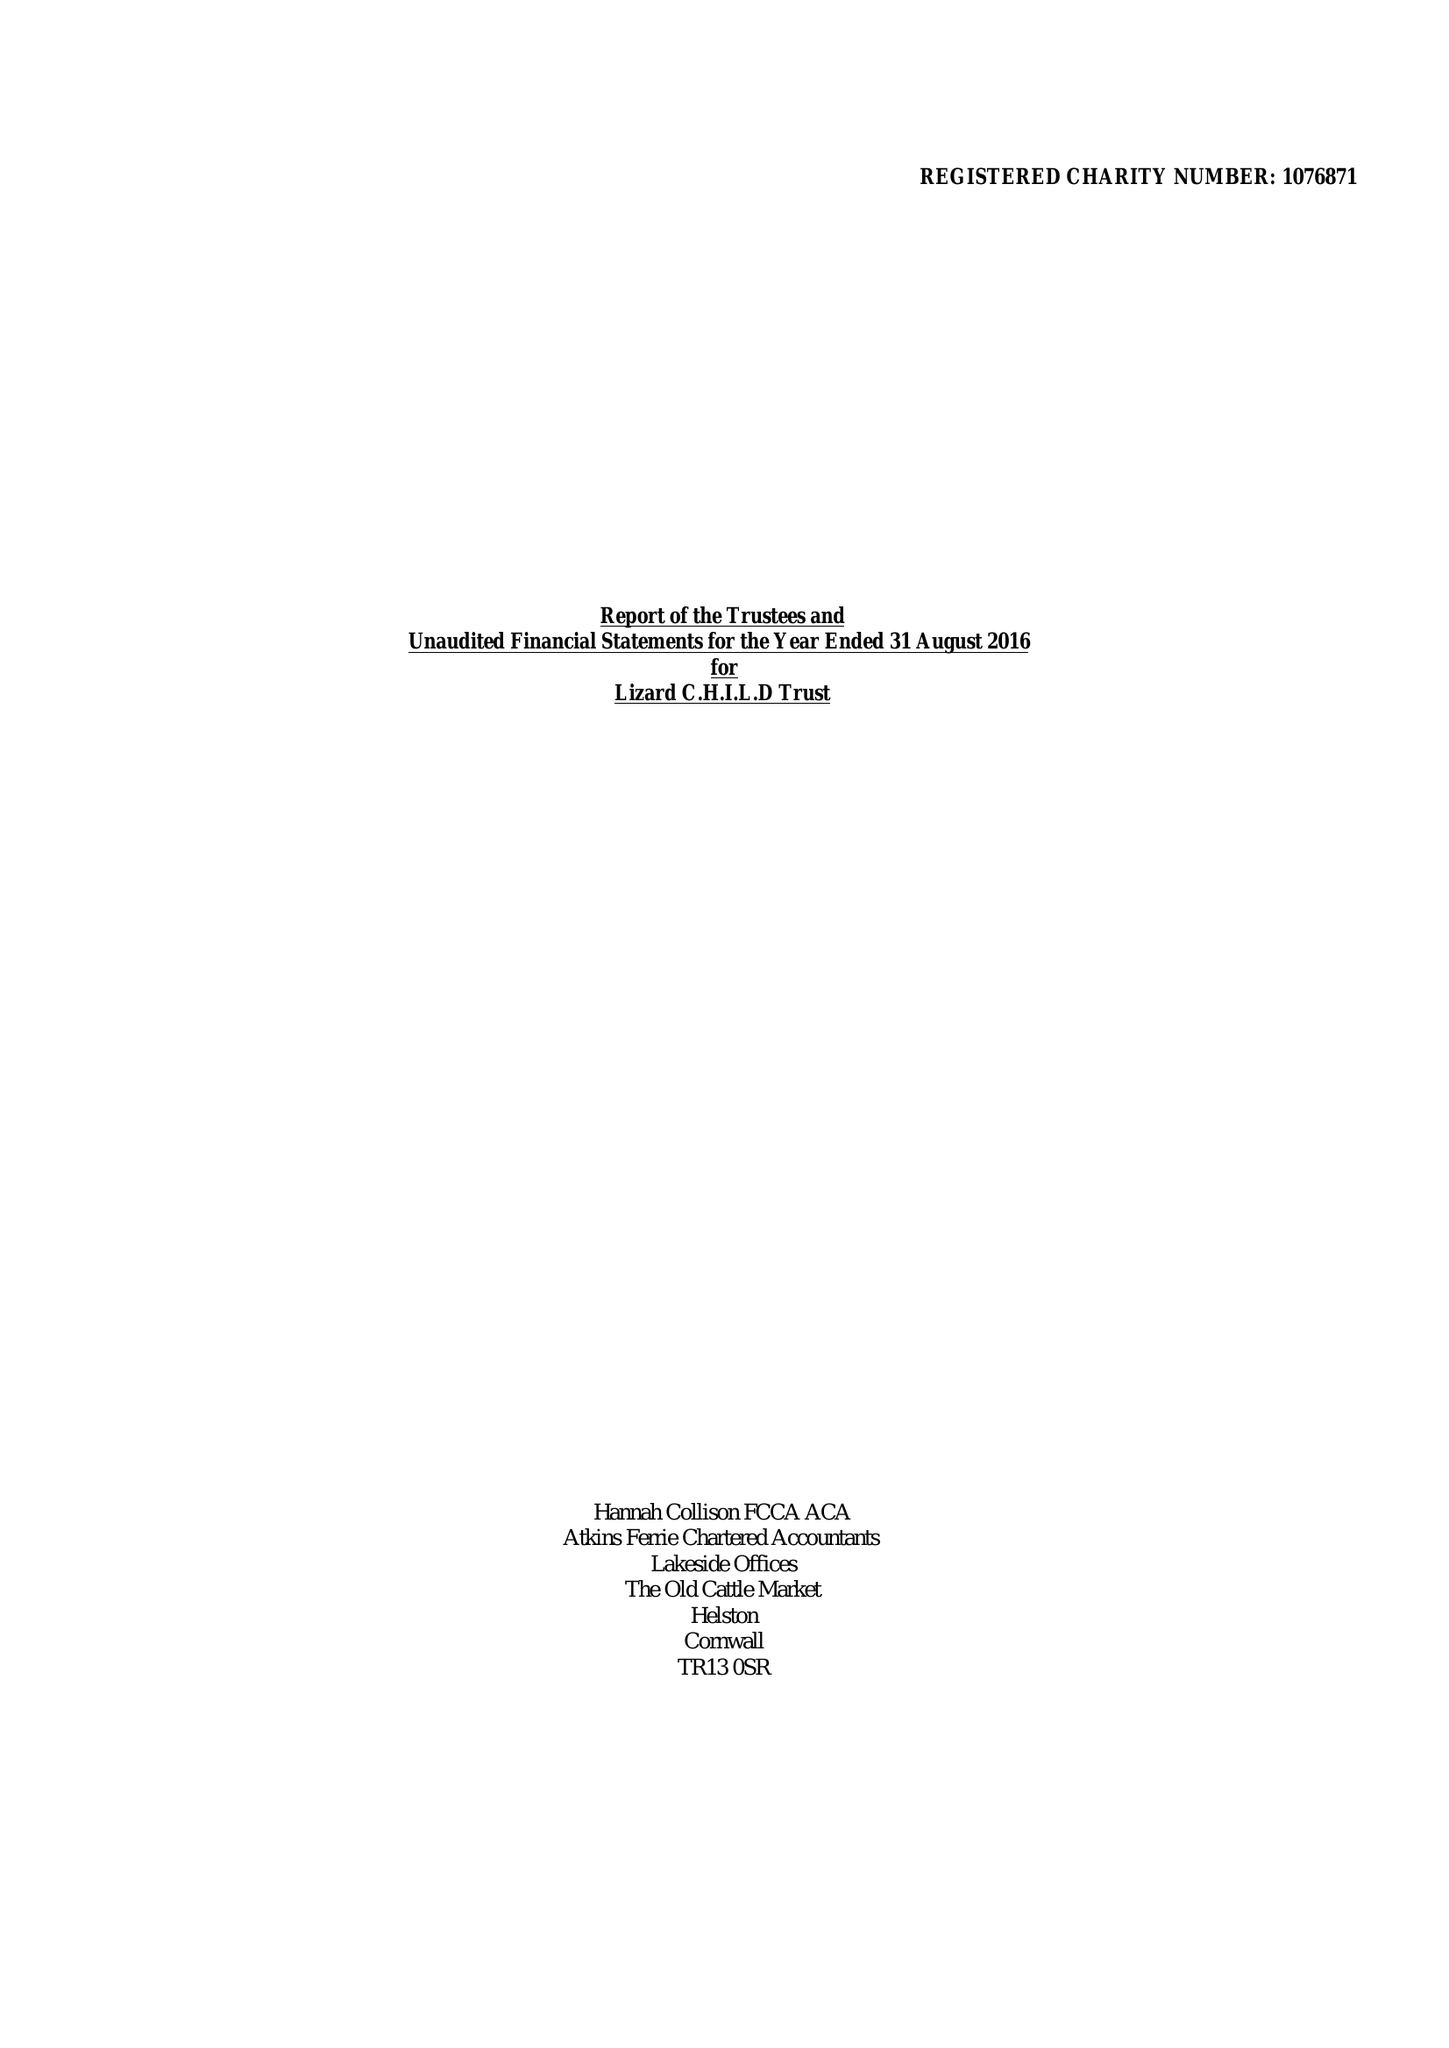What is the value for the address__post_town?
Answer the question using a single word or phrase. HELSTON 